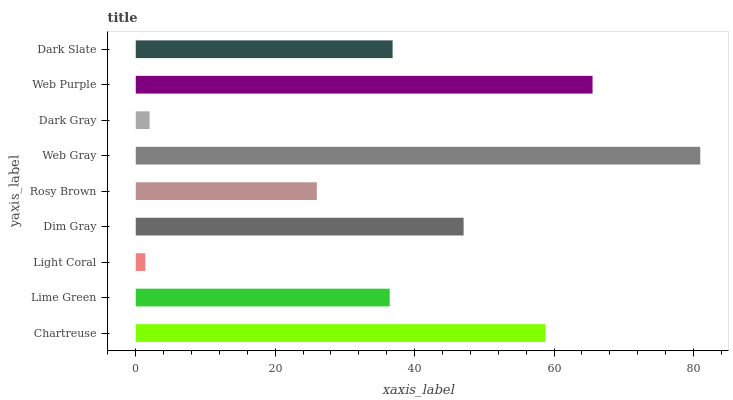Is Light Coral the minimum?
Answer yes or no. Yes. Is Web Gray the maximum?
Answer yes or no. Yes. Is Lime Green the minimum?
Answer yes or no. No. Is Lime Green the maximum?
Answer yes or no. No. Is Chartreuse greater than Lime Green?
Answer yes or no. Yes. Is Lime Green less than Chartreuse?
Answer yes or no. Yes. Is Lime Green greater than Chartreuse?
Answer yes or no. No. Is Chartreuse less than Lime Green?
Answer yes or no. No. Is Dark Slate the high median?
Answer yes or no. Yes. Is Dark Slate the low median?
Answer yes or no. Yes. Is Light Coral the high median?
Answer yes or no. No. Is Web Purple the low median?
Answer yes or no. No. 